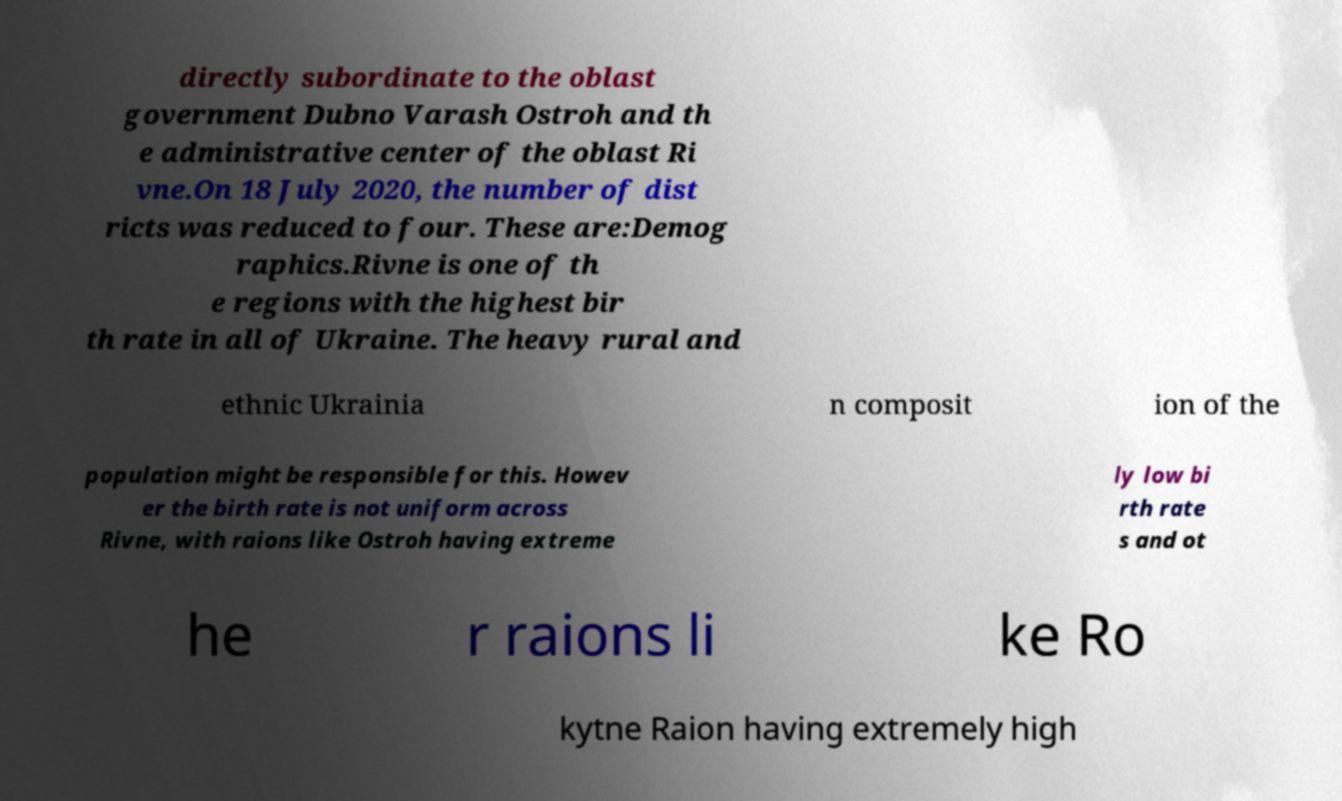I need the written content from this picture converted into text. Can you do that? directly subordinate to the oblast government Dubno Varash Ostroh and th e administrative center of the oblast Ri vne.On 18 July 2020, the number of dist ricts was reduced to four. These are:Demog raphics.Rivne is one of th e regions with the highest bir th rate in all of Ukraine. The heavy rural and ethnic Ukrainia n composit ion of the population might be responsible for this. Howev er the birth rate is not uniform across Rivne, with raions like Ostroh having extreme ly low bi rth rate s and ot he r raions li ke Ro kytne Raion having extremely high 